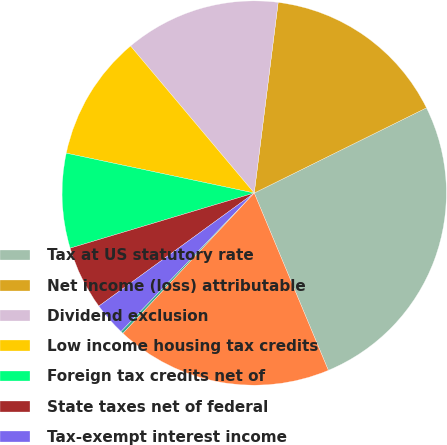Convert chart to OTSL. <chart><loc_0><loc_0><loc_500><loc_500><pie_chart><fcel>Tax at US statutory rate<fcel>Net income (loss) attributable<fcel>Dividend exclusion<fcel>Low income housing tax credits<fcel>Foreign tax credits net of<fcel>State taxes net of federal<fcel>Tax-exempt interest income<fcel>Other net<fcel>Income tax provision<nl><fcel>26.01%<fcel>15.7%<fcel>13.12%<fcel>10.54%<fcel>7.96%<fcel>5.38%<fcel>2.8%<fcel>0.22%<fcel>18.27%<nl></chart> 